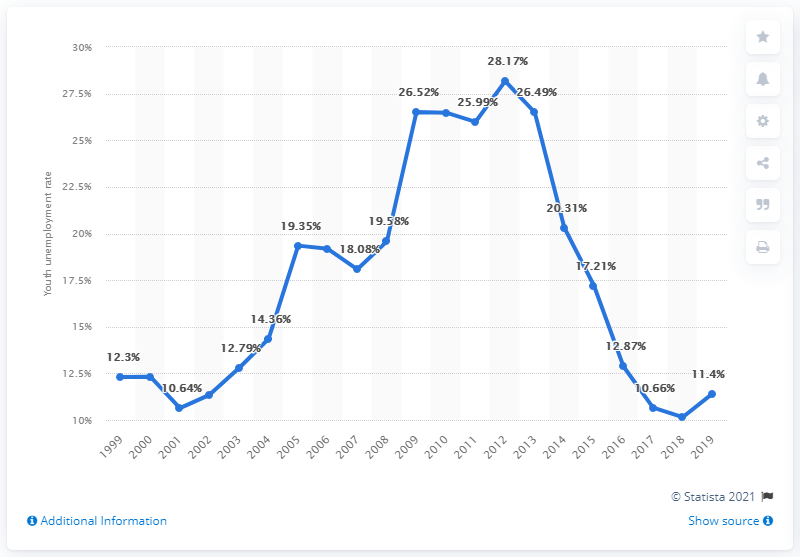Outline some significant characteristics in this image. In 2019, the youth unemployment rate in Hungary was 11.4%. 